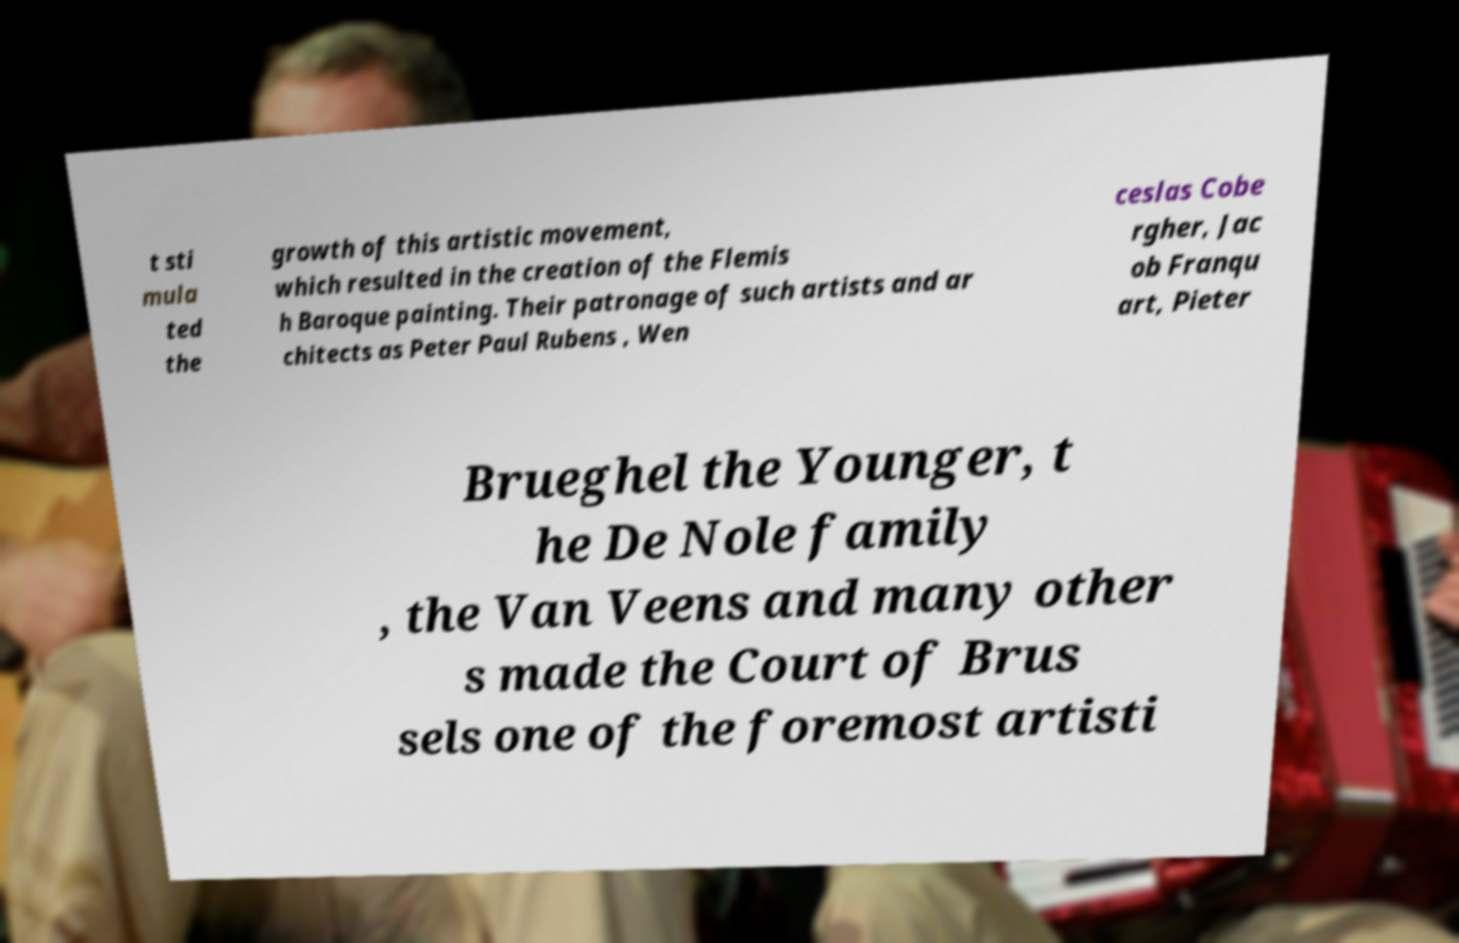Can you read and provide the text displayed in the image?This photo seems to have some interesting text. Can you extract and type it out for me? t sti mula ted the growth of this artistic movement, which resulted in the creation of the Flemis h Baroque painting. Their patronage of such artists and ar chitects as Peter Paul Rubens , Wen ceslas Cobe rgher, Jac ob Franqu art, Pieter Brueghel the Younger, t he De Nole family , the Van Veens and many other s made the Court of Brus sels one of the foremost artisti 